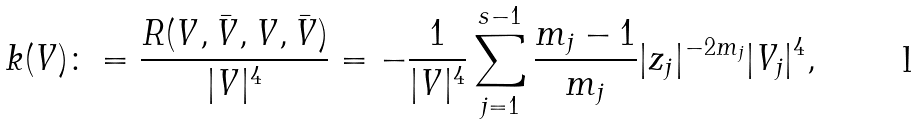<formula> <loc_0><loc_0><loc_500><loc_500>k ( V ) \colon = \frac { R ( V , \bar { V } , V , \bar { V } ) } { | V | ^ { 4 } } = - \frac { 1 } { | V | ^ { 4 } } \sum _ { j = 1 } ^ { s - 1 } \frac { m _ { j } - 1 } { m _ { j } } | z _ { j } | ^ { - 2 m _ { j } } | V _ { j } | ^ { 4 } ,</formula> 